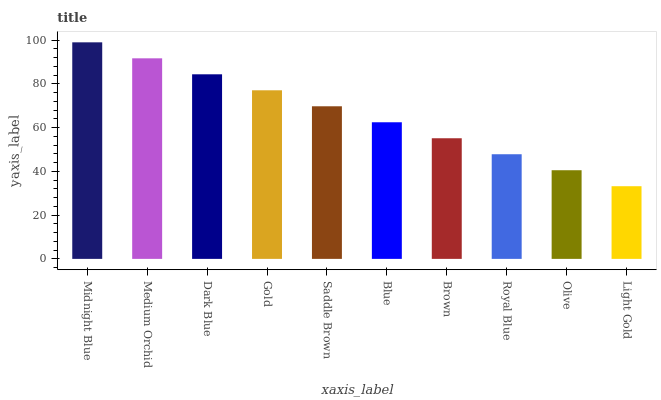Is Light Gold the minimum?
Answer yes or no. Yes. Is Midnight Blue the maximum?
Answer yes or no. Yes. Is Medium Orchid the minimum?
Answer yes or no. No. Is Medium Orchid the maximum?
Answer yes or no. No. Is Midnight Blue greater than Medium Orchid?
Answer yes or no. Yes. Is Medium Orchid less than Midnight Blue?
Answer yes or no. Yes. Is Medium Orchid greater than Midnight Blue?
Answer yes or no. No. Is Midnight Blue less than Medium Orchid?
Answer yes or no. No. Is Saddle Brown the high median?
Answer yes or no. Yes. Is Blue the low median?
Answer yes or no. Yes. Is Medium Orchid the high median?
Answer yes or no. No. Is Medium Orchid the low median?
Answer yes or no. No. 